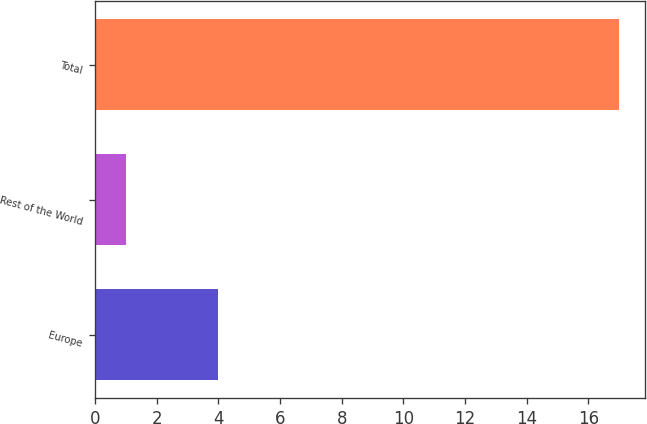Convert chart. <chart><loc_0><loc_0><loc_500><loc_500><bar_chart><fcel>Europe<fcel>Rest of the World<fcel>Total<nl><fcel>4<fcel>1<fcel>17<nl></chart> 